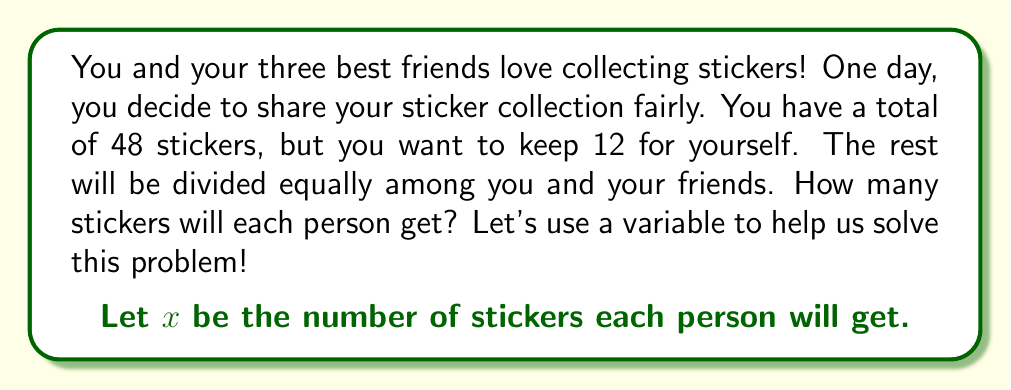Could you help me with this problem? Let's break this problem down into steps:

1. Understand the given information:
   - Total stickers: 48
   - Stickers you want to keep: 12
   - Number of people sharing: 4 (you and your three friends)

2. Calculate the number of stickers to be shared:
   $48 - 12 = 36$ stickers to be shared

3. Set up an equation:
   Since $x$ represents the number of stickers each person will get, and there are 4 people sharing, we can write:

   $4x = 36$

4. Solve the equation:
   $$\begin{align}
   4x &= 36 \\
   x &= 36 \div 4 \\
   x &= 9
   \end{align}$$

5. Check the answer:
   - Each person gets 9 stickers
   - 9 stickers × 4 people = 36 stickers (which matches the number to be shared)
   - You keep 12 stickers + 36 shared stickers = 48 total stickers (which matches the original total)

So, each person (including you) will get 9 stickers, and you'll have an extra 12 stickers for yourself.
Answer: Each person will get $9$ stickers. 